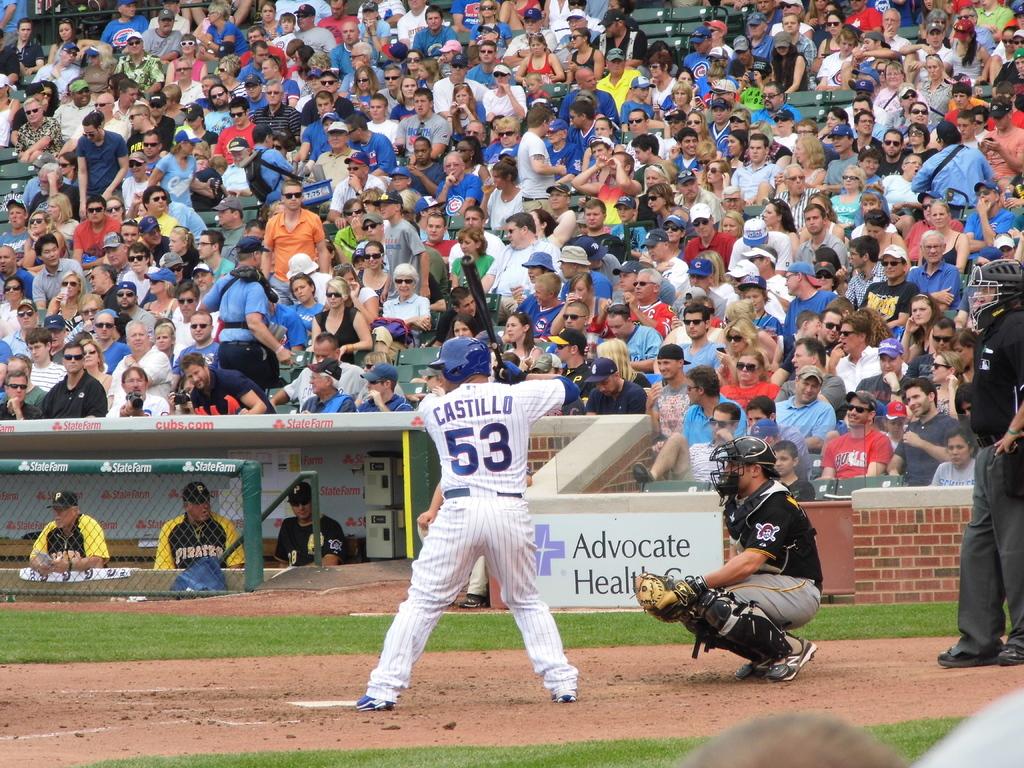Who is playing the game?
Ensure brevity in your answer.  Castillo. What number is on the white jersey?
Keep it short and to the point. 53. 